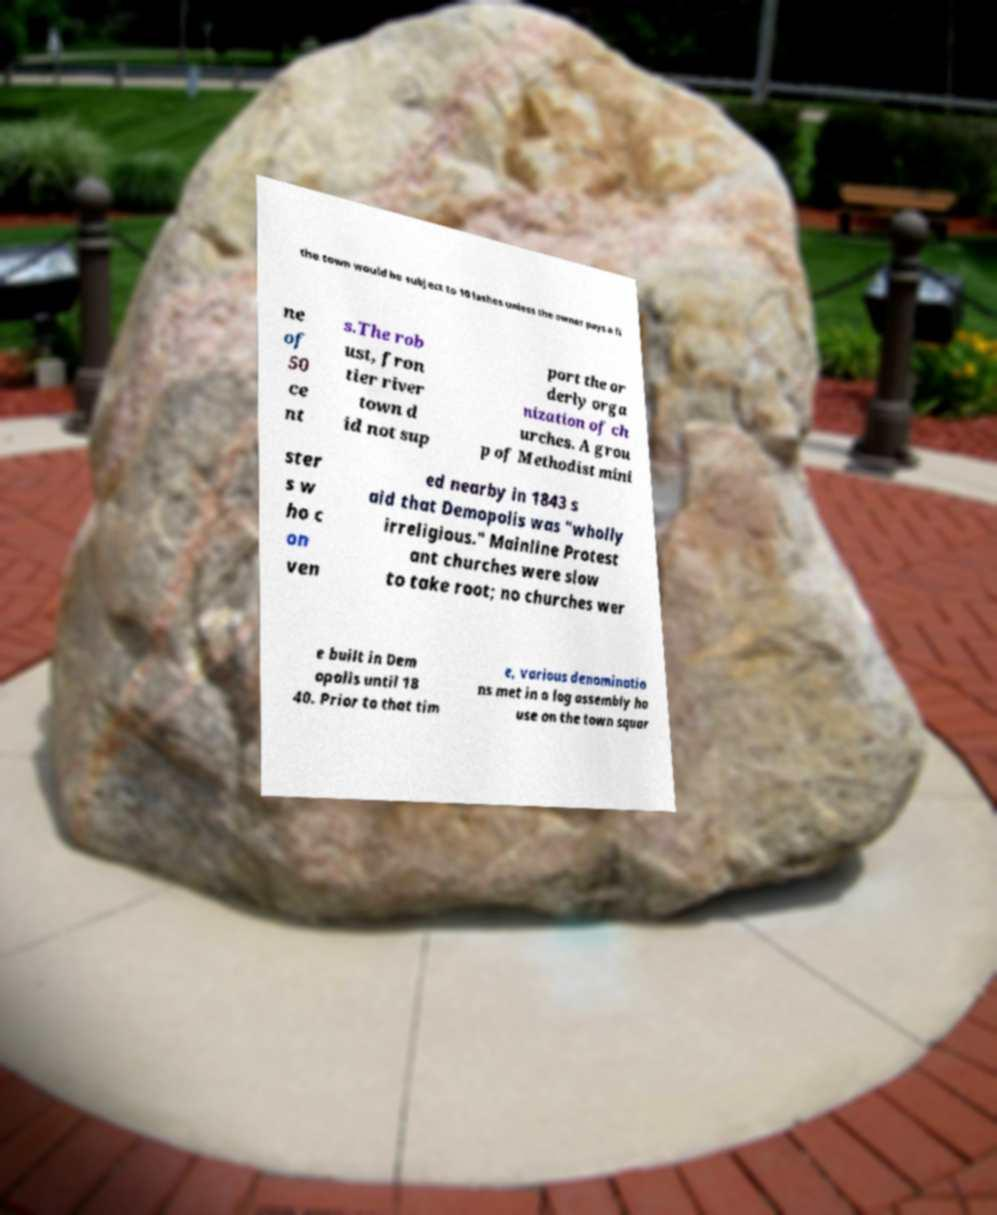Could you assist in decoding the text presented in this image and type it out clearly? the town would be subject to 10 lashes unless the owner pays a fi ne of 50 ce nt s.The rob ust, fron tier river town d id not sup port the or derly orga nization of ch urches. A grou p of Methodist mini ster s w ho c on ven ed nearby in 1843 s aid that Demopolis was "wholly irreligious." Mainline Protest ant churches were slow to take root; no churches wer e built in Dem opolis until 18 40. Prior to that tim e, various denominatio ns met in a log assembly ho use on the town squar 